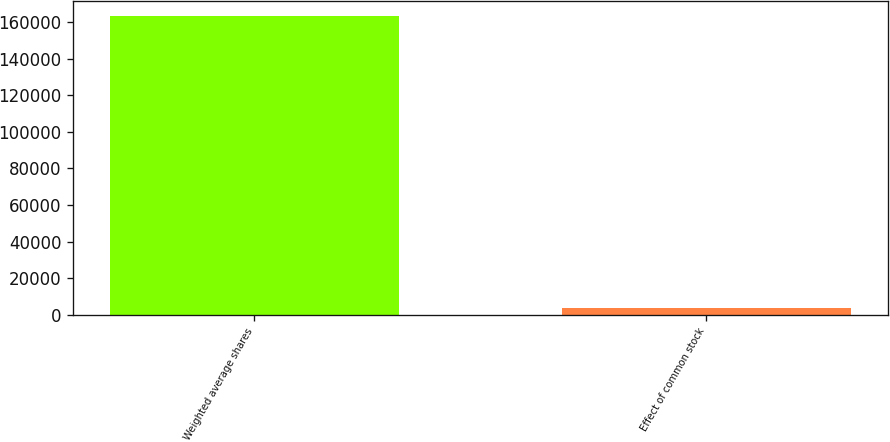<chart> <loc_0><loc_0><loc_500><loc_500><bar_chart><fcel>Weighted average shares<fcel>Effect of common stock<nl><fcel>163439<fcel>3736<nl></chart> 